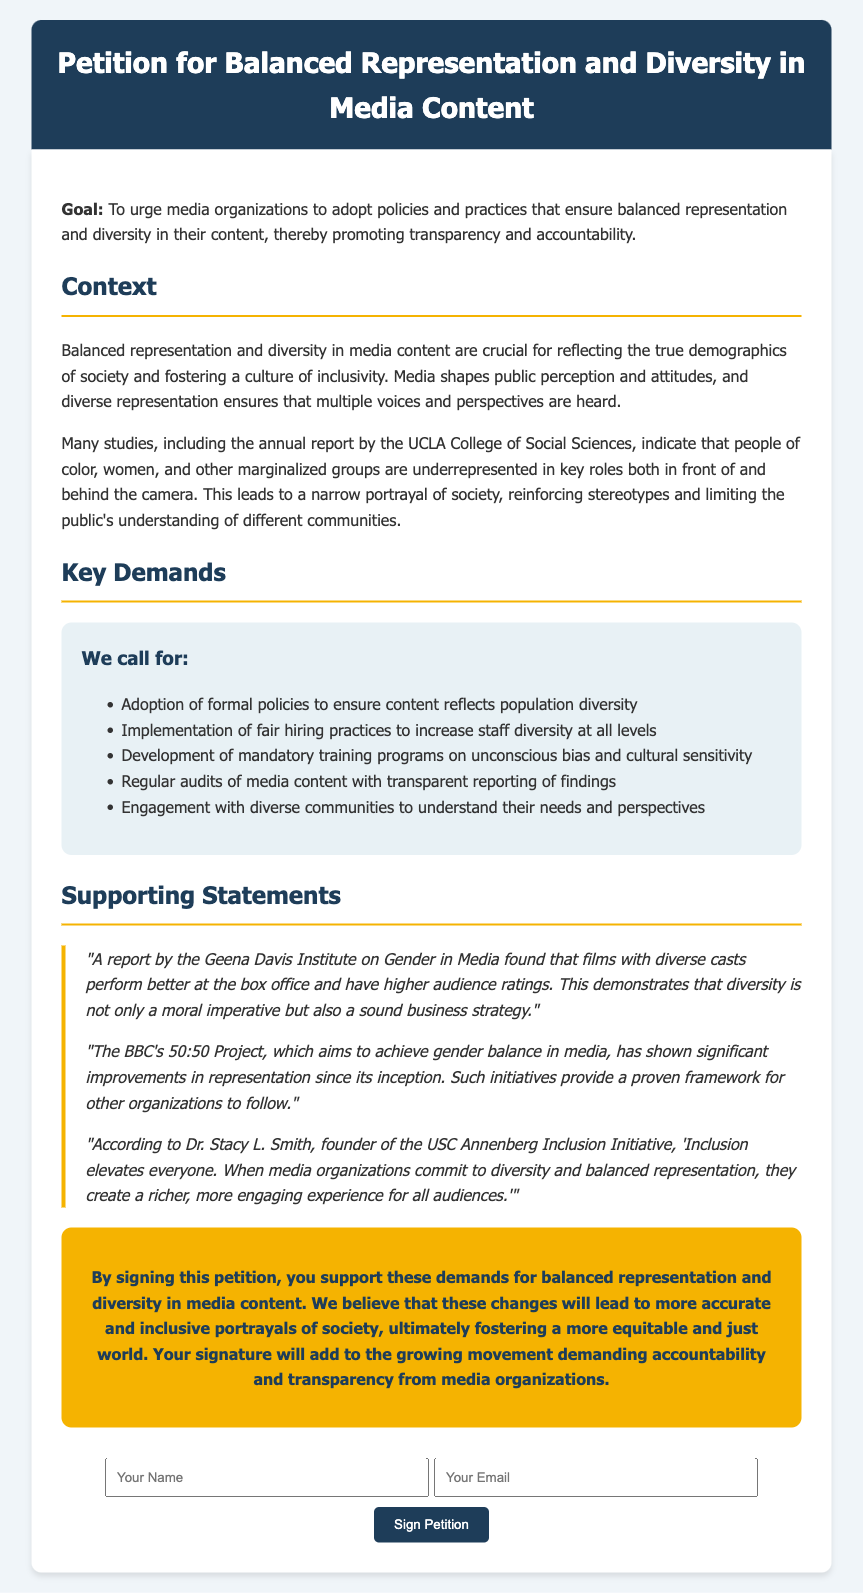What is the title of the petition? The title of the petition is presented in the header section of the document.
Answer: Petition for Balanced Representation and Diversity in Media Content What is the main goal of the petition? The goal is outlined in the introduction of the document and specifies the desired action from media organizations.
Answer: To urge media organizations to adopt policies and practices that ensure balanced representation and diversity in their content How many key demands are listed in the petition? The number of key demands is found in the section titled "Key Demands".
Answer: Five Who is the founder of the USC Annenberg Inclusion Initiative? This information is provided in a supporting statement within the document.
Answer: Dr. Stacy L. Smith What project does the BBC focus on for gender balance in media? The specific project is mentioned in one of the supporting statements, highlighting an initiative by the BBC.
Answer: 50:50 Project What type of training programs does the petition demand to be developed? This request is specified in the "Key Demands" section relating to staff training.
Answer: Mandatory training programs on unconscious bias and cultural sensitivity What phrase is used to describe the project by the Geena Davis Institute? This phrase is found in a supporting statement detailing the findings of a report.
Answer: Sound business strategy What action does signing the petition support? The purpose of signing the petition is clearly stated in the call-to-action section.
Answer: Support these demands for balanced representation and diversity in media content 